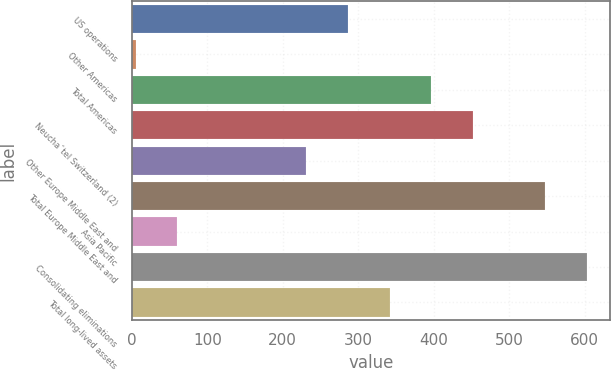Convert chart. <chart><loc_0><loc_0><loc_500><loc_500><bar_chart><fcel>US operations<fcel>Other Americas<fcel>Total Americas<fcel>Neuchaˆtel Switzerland (2)<fcel>Other Europe Middle East and<fcel>Total Europe Middle East and<fcel>Asia Pacific<fcel>Consolidating eliminations<fcel>Total long-lived assets<nl><fcel>286.17<fcel>5<fcel>397.11<fcel>452.58<fcel>230.7<fcel>548.2<fcel>60.47<fcel>603.67<fcel>341.64<nl></chart> 